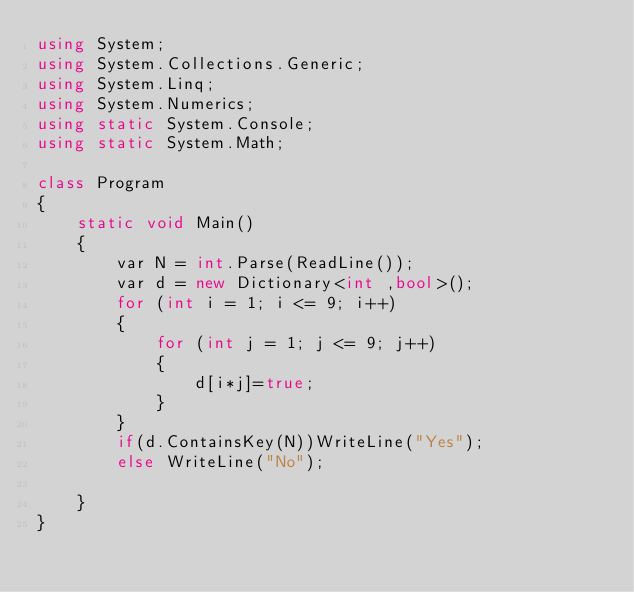<code> <loc_0><loc_0><loc_500><loc_500><_C#_>using System;
using System.Collections.Generic;
using System.Linq;
using System.Numerics;
using static System.Console;
using static System.Math;

class Program
{
    static void Main()
    {
        var N = int.Parse(ReadLine());
        var d = new Dictionary<int ,bool>();
        for (int i = 1; i <= 9; i++)
        {
            for (int j = 1; j <= 9; j++)
            {
                d[i*j]=true;
            }
        }
        if(d.ContainsKey(N))WriteLine("Yes");
        else WriteLine("No");

    }
}

</code> 